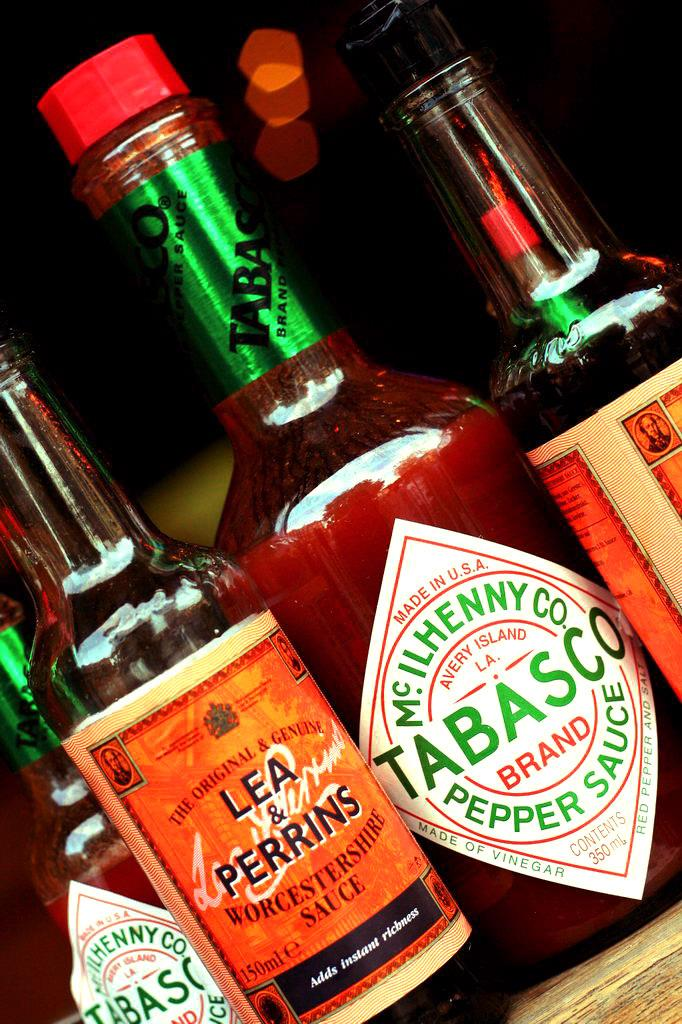<image>
Create a compact narrative representing the image presented. Many bottles together with one that says Tabasco on it. 